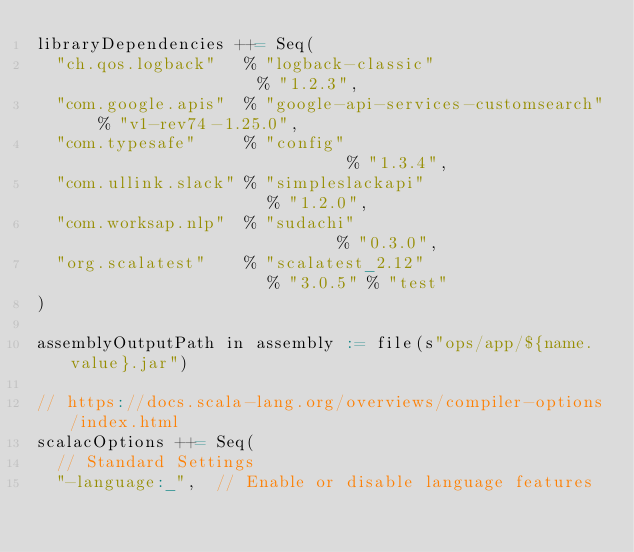<code> <loc_0><loc_0><loc_500><loc_500><_Scala_>libraryDependencies ++= Seq(
  "ch.qos.logback"   % "logback-classic"                  % "1.2.3",
  "com.google.apis"  % "google-api-services-customsearch" % "v1-rev74-1.25.0",
  "com.typesafe"     % "config"                           % "1.3.4",
  "com.ullink.slack" % "simpleslackapi"                   % "1.2.0",
  "com.worksap.nlp"  % "sudachi"                          % "0.3.0",
  "org.scalatest"    % "scalatest_2.12"                   % "3.0.5" % "test"
)

assemblyOutputPath in assembly := file(s"ops/app/${name.value}.jar")

// https://docs.scala-lang.org/overviews/compiler-options/index.html
scalacOptions ++= Seq(
  // Standard Settings
  "-language:_",  // Enable or disable language features</code> 